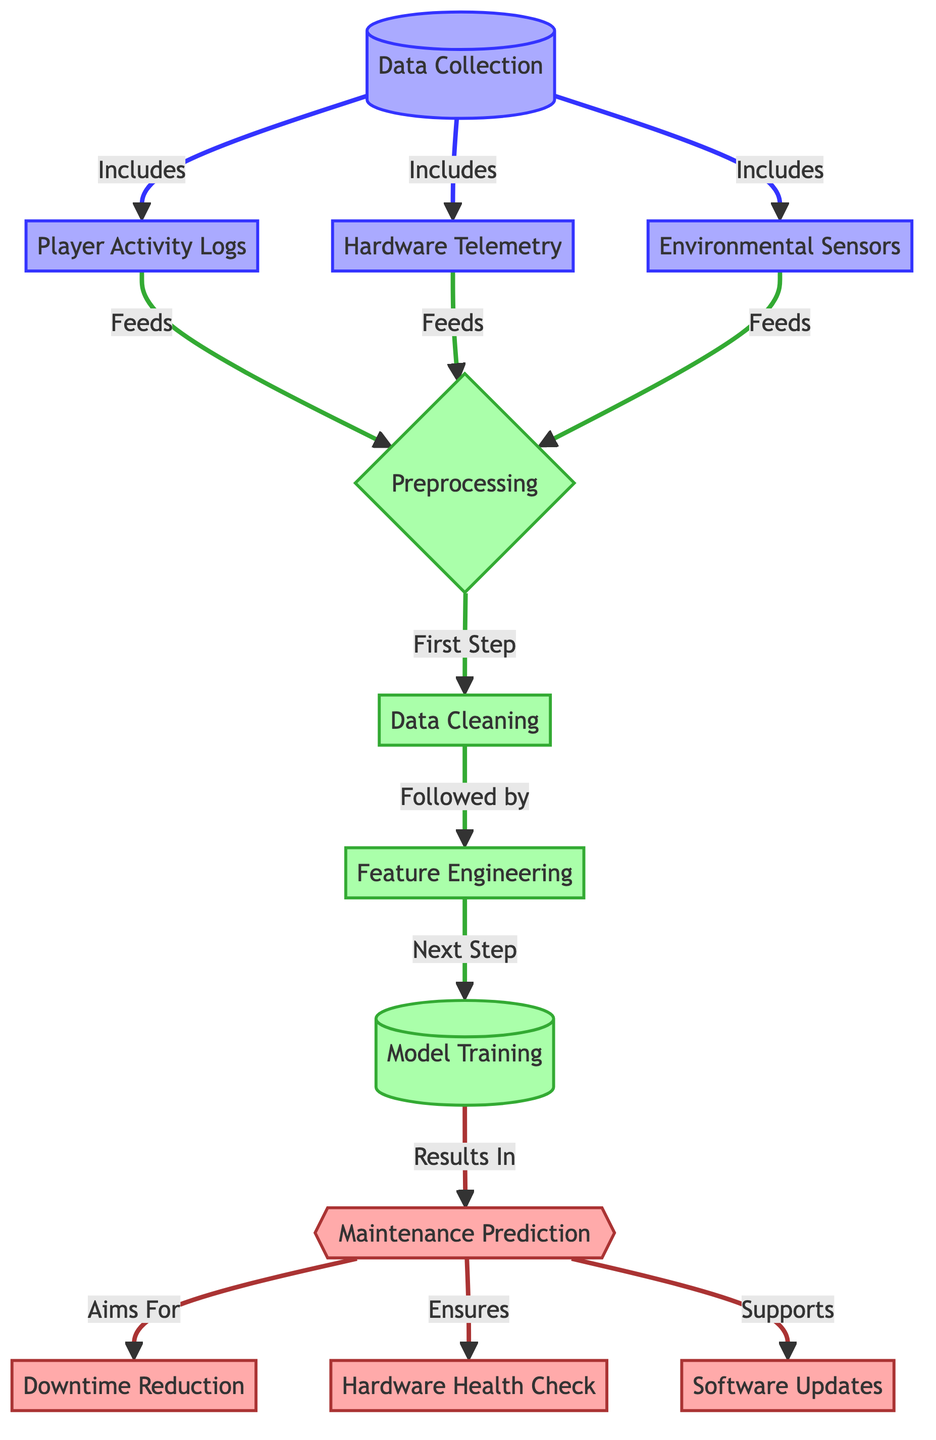What does the diagram visualize? The diagram visualizes the process of predictive maintenance, detailing how data collection, preprocessing, model training, and maintenance prediction interact to reduce downtime and ensure hardware health in a gaming equipment context.
Answer: Predictive maintenance process How many data sources are used in this diagram? There are three data sources illustrated: Player Activity Logs, Hardware Telemetry, and Environmental Sensors, all feeding into the data collection process.
Answer: Three Which process follows data cleaning? The process that follows data cleaning is feature engineering. This step is critical as it involves creating new features that help improve the effectiveness of the model training.
Answer: Feature engineering What is the primary output of the model training? The primary output of the model training is maintenance prediction, which serves as the basis for further actions like downtime reduction and hardware health check.
Answer: Maintenance prediction What does maintenance prediction aim to achieve? Maintenance prediction aims to achieve downtime reduction, which is crucial for maintaining the operational availability of gaming equipment in the esports environment.
Answer: Downtime reduction What ensures hardware health check according to the diagram? The maintenance prediction directly ensures the hardware health check by anticipating potential issues before they lead to failure, allowing for proactive measures to be taken.
Answer: Maintenance prediction What is the first step after data collection? The first step after data collection is preprocessing, where the collected data is prepared for analysis and model training through various techniques such as cleaning and feature selection.
Answer: Preprocessing How many steps are there in the preprocessing phase? There are three distinct steps in the preprocessing phase: data cleaning, feature engineering, and preparing for model training.
Answer: Three steps Which process does model training directly support? Model training directly supports the software updates process by providing predictive insights that inform when updates are necessary to optimize performance.
Answer: Software updates 